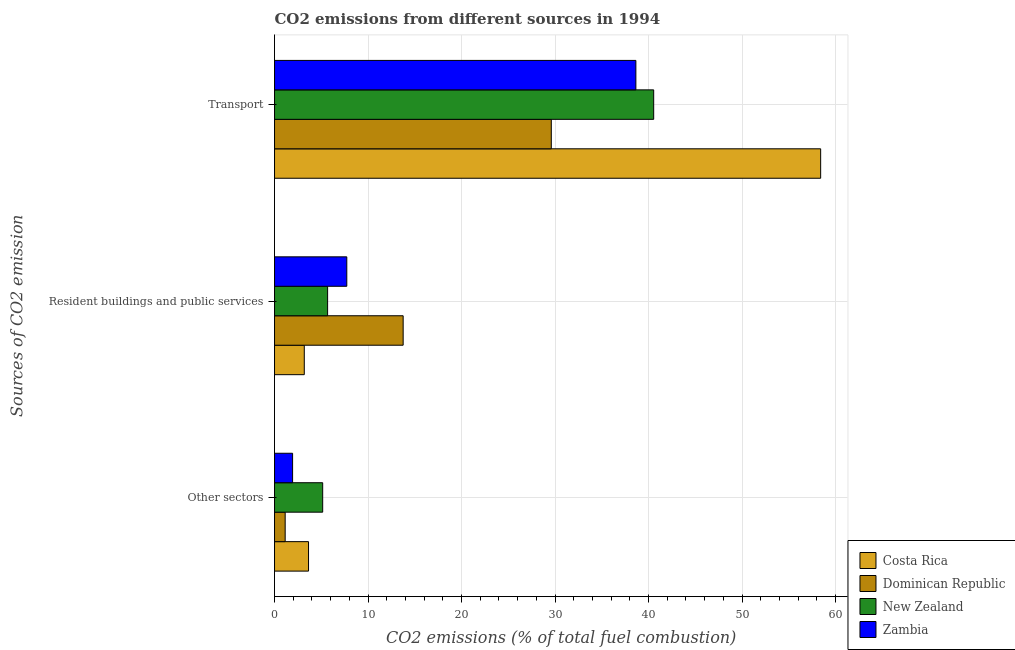How many groups of bars are there?
Your answer should be compact. 3. Are the number of bars per tick equal to the number of legend labels?
Ensure brevity in your answer.  Yes. How many bars are there on the 3rd tick from the top?
Keep it short and to the point. 4. What is the label of the 3rd group of bars from the top?
Offer a very short reply. Other sectors. What is the percentage of co2 emissions from transport in New Zealand?
Offer a very short reply. 40.55. Across all countries, what is the maximum percentage of co2 emissions from other sectors?
Ensure brevity in your answer.  5.15. Across all countries, what is the minimum percentage of co2 emissions from resident buildings and public services?
Your answer should be very brief. 3.18. In which country was the percentage of co2 emissions from resident buildings and public services maximum?
Make the answer very short. Dominican Republic. What is the total percentage of co2 emissions from other sectors in the graph?
Your answer should be very brief. 11.86. What is the difference between the percentage of co2 emissions from resident buildings and public services in Zambia and that in Dominican Republic?
Your answer should be very brief. -6.03. What is the difference between the percentage of co2 emissions from other sectors in Zambia and the percentage of co2 emissions from transport in Dominican Republic?
Your response must be concise. -27.67. What is the average percentage of co2 emissions from resident buildings and public services per country?
Offer a very short reply. 7.59. What is the difference between the percentage of co2 emissions from other sectors and percentage of co2 emissions from resident buildings and public services in Dominican Republic?
Your answer should be very brief. -12.62. What is the ratio of the percentage of co2 emissions from resident buildings and public services in Costa Rica to that in Dominican Republic?
Provide a short and direct response. 0.23. Is the difference between the percentage of co2 emissions from resident buildings and public services in New Zealand and Costa Rica greater than the difference between the percentage of co2 emissions from transport in New Zealand and Costa Rica?
Make the answer very short. Yes. What is the difference between the highest and the second highest percentage of co2 emissions from other sectors?
Give a very brief answer. 1.51. What is the difference between the highest and the lowest percentage of co2 emissions from resident buildings and public services?
Ensure brevity in your answer.  10.58. In how many countries, is the percentage of co2 emissions from transport greater than the average percentage of co2 emissions from transport taken over all countries?
Offer a very short reply. 1. Is the sum of the percentage of co2 emissions from transport in Costa Rica and Dominican Republic greater than the maximum percentage of co2 emissions from resident buildings and public services across all countries?
Your answer should be very brief. Yes. What does the 3rd bar from the top in Other sectors represents?
Your answer should be very brief. Dominican Republic. What does the 4th bar from the bottom in Resident buildings and public services represents?
Offer a terse response. Zambia. Are all the bars in the graph horizontal?
Keep it short and to the point. Yes. Does the graph contain any zero values?
Make the answer very short. No. How many legend labels are there?
Provide a succinct answer. 4. How are the legend labels stacked?
Give a very brief answer. Vertical. What is the title of the graph?
Make the answer very short. CO2 emissions from different sources in 1994. What is the label or title of the X-axis?
Offer a terse response. CO2 emissions (% of total fuel combustion). What is the label or title of the Y-axis?
Make the answer very short. Sources of CO2 emission. What is the CO2 emissions (% of total fuel combustion) of Costa Rica in Other sectors?
Your answer should be compact. 3.64. What is the CO2 emissions (% of total fuel combustion) of Dominican Republic in Other sectors?
Keep it short and to the point. 1.14. What is the CO2 emissions (% of total fuel combustion) in New Zealand in Other sectors?
Provide a short and direct response. 5.15. What is the CO2 emissions (% of total fuel combustion) in Zambia in Other sectors?
Offer a very short reply. 1.93. What is the CO2 emissions (% of total fuel combustion) of Costa Rica in Resident buildings and public services?
Keep it short and to the point. 3.18. What is the CO2 emissions (% of total fuel combustion) in Dominican Republic in Resident buildings and public services?
Make the answer very short. 13.76. What is the CO2 emissions (% of total fuel combustion) in New Zealand in Resident buildings and public services?
Your response must be concise. 5.68. What is the CO2 emissions (% of total fuel combustion) of Zambia in Resident buildings and public services?
Give a very brief answer. 7.73. What is the CO2 emissions (% of total fuel combustion) in Costa Rica in Transport?
Keep it short and to the point. 58.41. What is the CO2 emissions (% of total fuel combustion) in Dominican Republic in Transport?
Offer a very short reply. 29.6. What is the CO2 emissions (% of total fuel combustion) in New Zealand in Transport?
Keep it short and to the point. 40.55. What is the CO2 emissions (% of total fuel combustion) in Zambia in Transport?
Offer a terse response. 38.65. Across all Sources of CO2 emission, what is the maximum CO2 emissions (% of total fuel combustion) in Costa Rica?
Provide a short and direct response. 58.41. Across all Sources of CO2 emission, what is the maximum CO2 emissions (% of total fuel combustion) in Dominican Republic?
Ensure brevity in your answer.  29.6. Across all Sources of CO2 emission, what is the maximum CO2 emissions (% of total fuel combustion) of New Zealand?
Make the answer very short. 40.55. Across all Sources of CO2 emission, what is the maximum CO2 emissions (% of total fuel combustion) in Zambia?
Your answer should be compact. 38.65. Across all Sources of CO2 emission, what is the minimum CO2 emissions (% of total fuel combustion) in Costa Rica?
Offer a very short reply. 3.18. Across all Sources of CO2 emission, what is the minimum CO2 emissions (% of total fuel combustion) of Dominican Republic?
Your response must be concise. 1.14. Across all Sources of CO2 emission, what is the minimum CO2 emissions (% of total fuel combustion) of New Zealand?
Provide a short and direct response. 5.15. Across all Sources of CO2 emission, what is the minimum CO2 emissions (% of total fuel combustion) in Zambia?
Give a very brief answer. 1.93. What is the total CO2 emissions (% of total fuel combustion) in Costa Rica in the graph?
Provide a succinct answer. 65.23. What is the total CO2 emissions (% of total fuel combustion) in Dominican Republic in the graph?
Keep it short and to the point. 44.5. What is the total CO2 emissions (% of total fuel combustion) of New Zealand in the graph?
Give a very brief answer. 51.38. What is the total CO2 emissions (% of total fuel combustion) in Zambia in the graph?
Give a very brief answer. 48.31. What is the difference between the CO2 emissions (% of total fuel combustion) in Costa Rica in Other sectors and that in Resident buildings and public services?
Give a very brief answer. 0.45. What is the difference between the CO2 emissions (% of total fuel combustion) in Dominican Republic in Other sectors and that in Resident buildings and public services?
Give a very brief answer. -12.62. What is the difference between the CO2 emissions (% of total fuel combustion) in New Zealand in Other sectors and that in Resident buildings and public services?
Provide a short and direct response. -0.53. What is the difference between the CO2 emissions (% of total fuel combustion) of Zambia in Other sectors and that in Resident buildings and public services?
Provide a short and direct response. -5.8. What is the difference between the CO2 emissions (% of total fuel combustion) of Costa Rica in Other sectors and that in Transport?
Keep it short and to the point. -54.77. What is the difference between the CO2 emissions (% of total fuel combustion) of Dominican Republic in Other sectors and that in Transport?
Offer a very short reply. -28.46. What is the difference between the CO2 emissions (% of total fuel combustion) in New Zealand in Other sectors and that in Transport?
Offer a terse response. -35.4. What is the difference between the CO2 emissions (% of total fuel combustion) in Zambia in Other sectors and that in Transport?
Your answer should be compact. -36.72. What is the difference between the CO2 emissions (% of total fuel combustion) of Costa Rica in Resident buildings and public services and that in Transport?
Offer a terse response. -55.23. What is the difference between the CO2 emissions (% of total fuel combustion) in Dominican Republic in Resident buildings and public services and that in Transport?
Your answer should be compact. -15.84. What is the difference between the CO2 emissions (% of total fuel combustion) in New Zealand in Resident buildings and public services and that in Transport?
Provide a short and direct response. -34.87. What is the difference between the CO2 emissions (% of total fuel combustion) of Zambia in Resident buildings and public services and that in Transport?
Offer a terse response. -30.92. What is the difference between the CO2 emissions (% of total fuel combustion) of Costa Rica in Other sectors and the CO2 emissions (% of total fuel combustion) of Dominican Republic in Resident buildings and public services?
Offer a very short reply. -10.12. What is the difference between the CO2 emissions (% of total fuel combustion) of Costa Rica in Other sectors and the CO2 emissions (% of total fuel combustion) of New Zealand in Resident buildings and public services?
Your answer should be very brief. -2.04. What is the difference between the CO2 emissions (% of total fuel combustion) of Costa Rica in Other sectors and the CO2 emissions (% of total fuel combustion) of Zambia in Resident buildings and public services?
Keep it short and to the point. -4.09. What is the difference between the CO2 emissions (% of total fuel combustion) in Dominican Republic in Other sectors and the CO2 emissions (% of total fuel combustion) in New Zealand in Resident buildings and public services?
Provide a short and direct response. -4.54. What is the difference between the CO2 emissions (% of total fuel combustion) of Dominican Republic in Other sectors and the CO2 emissions (% of total fuel combustion) of Zambia in Resident buildings and public services?
Your answer should be compact. -6.59. What is the difference between the CO2 emissions (% of total fuel combustion) in New Zealand in Other sectors and the CO2 emissions (% of total fuel combustion) in Zambia in Resident buildings and public services?
Give a very brief answer. -2.58. What is the difference between the CO2 emissions (% of total fuel combustion) in Costa Rica in Other sectors and the CO2 emissions (% of total fuel combustion) in Dominican Republic in Transport?
Give a very brief answer. -25.97. What is the difference between the CO2 emissions (% of total fuel combustion) in Costa Rica in Other sectors and the CO2 emissions (% of total fuel combustion) in New Zealand in Transport?
Provide a short and direct response. -36.92. What is the difference between the CO2 emissions (% of total fuel combustion) of Costa Rica in Other sectors and the CO2 emissions (% of total fuel combustion) of Zambia in Transport?
Ensure brevity in your answer.  -35.01. What is the difference between the CO2 emissions (% of total fuel combustion) in Dominican Republic in Other sectors and the CO2 emissions (% of total fuel combustion) in New Zealand in Transport?
Ensure brevity in your answer.  -39.41. What is the difference between the CO2 emissions (% of total fuel combustion) in Dominican Republic in Other sectors and the CO2 emissions (% of total fuel combustion) in Zambia in Transport?
Provide a short and direct response. -37.51. What is the difference between the CO2 emissions (% of total fuel combustion) in New Zealand in Other sectors and the CO2 emissions (% of total fuel combustion) in Zambia in Transport?
Your answer should be compact. -33.5. What is the difference between the CO2 emissions (% of total fuel combustion) of Costa Rica in Resident buildings and public services and the CO2 emissions (% of total fuel combustion) of Dominican Republic in Transport?
Your answer should be compact. -26.42. What is the difference between the CO2 emissions (% of total fuel combustion) of Costa Rica in Resident buildings and public services and the CO2 emissions (% of total fuel combustion) of New Zealand in Transport?
Offer a very short reply. -37.37. What is the difference between the CO2 emissions (% of total fuel combustion) in Costa Rica in Resident buildings and public services and the CO2 emissions (% of total fuel combustion) in Zambia in Transport?
Make the answer very short. -35.47. What is the difference between the CO2 emissions (% of total fuel combustion) of Dominican Republic in Resident buildings and public services and the CO2 emissions (% of total fuel combustion) of New Zealand in Transport?
Your answer should be very brief. -26.79. What is the difference between the CO2 emissions (% of total fuel combustion) of Dominican Republic in Resident buildings and public services and the CO2 emissions (% of total fuel combustion) of Zambia in Transport?
Your response must be concise. -24.89. What is the difference between the CO2 emissions (% of total fuel combustion) in New Zealand in Resident buildings and public services and the CO2 emissions (% of total fuel combustion) in Zambia in Transport?
Offer a terse response. -32.97. What is the average CO2 emissions (% of total fuel combustion) of Costa Rica per Sources of CO2 emission?
Your answer should be compact. 21.74. What is the average CO2 emissions (% of total fuel combustion) of Dominican Republic per Sources of CO2 emission?
Provide a short and direct response. 14.83. What is the average CO2 emissions (% of total fuel combustion) of New Zealand per Sources of CO2 emission?
Make the answer very short. 17.13. What is the average CO2 emissions (% of total fuel combustion) in Zambia per Sources of CO2 emission?
Ensure brevity in your answer.  16.1. What is the difference between the CO2 emissions (% of total fuel combustion) of Costa Rica and CO2 emissions (% of total fuel combustion) of Dominican Republic in Other sectors?
Keep it short and to the point. 2.5. What is the difference between the CO2 emissions (% of total fuel combustion) in Costa Rica and CO2 emissions (% of total fuel combustion) in New Zealand in Other sectors?
Give a very brief answer. -1.51. What is the difference between the CO2 emissions (% of total fuel combustion) in Costa Rica and CO2 emissions (% of total fuel combustion) in Zambia in Other sectors?
Your response must be concise. 1.7. What is the difference between the CO2 emissions (% of total fuel combustion) of Dominican Republic and CO2 emissions (% of total fuel combustion) of New Zealand in Other sectors?
Your response must be concise. -4.01. What is the difference between the CO2 emissions (% of total fuel combustion) of Dominican Republic and CO2 emissions (% of total fuel combustion) of Zambia in Other sectors?
Keep it short and to the point. -0.79. What is the difference between the CO2 emissions (% of total fuel combustion) in New Zealand and CO2 emissions (% of total fuel combustion) in Zambia in Other sectors?
Offer a terse response. 3.22. What is the difference between the CO2 emissions (% of total fuel combustion) in Costa Rica and CO2 emissions (% of total fuel combustion) in Dominican Republic in Resident buildings and public services?
Your response must be concise. -10.58. What is the difference between the CO2 emissions (% of total fuel combustion) of Costa Rica and CO2 emissions (% of total fuel combustion) of New Zealand in Resident buildings and public services?
Provide a short and direct response. -2.5. What is the difference between the CO2 emissions (% of total fuel combustion) in Costa Rica and CO2 emissions (% of total fuel combustion) in Zambia in Resident buildings and public services?
Give a very brief answer. -4.55. What is the difference between the CO2 emissions (% of total fuel combustion) of Dominican Republic and CO2 emissions (% of total fuel combustion) of New Zealand in Resident buildings and public services?
Offer a very short reply. 8.08. What is the difference between the CO2 emissions (% of total fuel combustion) in Dominican Republic and CO2 emissions (% of total fuel combustion) in Zambia in Resident buildings and public services?
Keep it short and to the point. 6.03. What is the difference between the CO2 emissions (% of total fuel combustion) of New Zealand and CO2 emissions (% of total fuel combustion) of Zambia in Resident buildings and public services?
Your response must be concise. -2.05. What is the difference between the CO2 emissions (% of total fuel combustion) of Costa Rica and CO2 emissions (% of total fuel combustion) of Dominican Republic in Transport?
Provide a short and direct response. 28.81. What is the difference between the CO2 emissions (% of total fuel combustion) of Costa Rica and CO2 emissions (% of total fuel combustion) of New Zealand in Transport?
Keep it short and to the point. 17.86. What is the difference between the CO2 emissions (% of total fuel combustion) of Costa Rica and CO2 emissions (% of total fuel combustion) of Zambia in Transport?
Make the answer very short. 19.76. What is the difference between the CO2 emissions (% of total fuel combustion) in Dominican Republic and CO2 emissions (% of total fuel combustion) in New Zealand in Transport?
Provide a succinct answer. -10.95. What is the difference between the CO2 emissions (% of total fuel combustion) of Dominican Republic and CO2 emissions (% of total fuel combustion) of Zambia in Transport?
Your answer should be very brief. -9.05. What is the difference between the CO2 emissions (% of total fuel combustion) of New Zealand and CO2 emissions (% of total fuel combustion) of Zambia in Transport?
Keep it short and to the point. 1.9. What is the ratio of the CO2 emissions (% of total fuel combustion) of Dominican Republic in Other sectors to that in Resident buildings and public services?
Offer a very short reply. 0.08. What is the ratio of the CO2 emissions (% of total fuel combustion) in New Zealand in Other sectors to that in Resident buildings and public services?
Give a very brief answer. 0.91. What is the ratio of the CO2 emissions (% of total fuel combustion) in Costa Rica in Other sectors to that in Transport?
Your answer should be very brief. 0.06. What is the ratio of the CO2 emissions (% of total fuel combustion) of Dominican Republic in Other sectors to that in Transport?
Offer a terse response. 0.04. What is the ratio of the CO2 emissions (% of total fuel combustion) in New Zealand in Other sectors to that in Transport?
Your answer should be compact. 0.13. What is the ratio of the CO2 emissions (% of total fuel combustion) in Zambia in Other sectors to that in Transport?
Ensure brevity in your answer.  0.05. What is the ratio of the CO2 emissions (% of total fuel combustion) of Costa Rica in Resident buildings and public services to that in Transport?
Keep it short and to the point. 0.05. What is the ratio of the CO2 emissions (% of total fuel combustion) in Dominican Republic in Resident buildings and public services to that in Transport?
Keep it short and to the point. 0.46. What is the ratio of the CO2 emissions (% of total fuel combustion) in New Zealand in Resident buildings and public services to that in Transport?
Offer a terse response. 0.14. What is the ratio of the CO2 emissions (% of total fuel combustion) of Zambia in Resident buildings and public services to that in Transport?
Keep it short and to the point. 0.2. What is the difference between the highest and the second highest CO2 emissions (% of total fuel combustion) in Costa Rica?
Give a very brief answer. 54.77. What is the difference between the highest and the second highest CO2 emissions (% of total fuel combustion) of Dominican Republic?
Offer a very short reply. 15.84. What is the difference between the highest and the second highest CO2 emissions (% of total fuel combustion) in New Zealand?
Give a very brief answer. 34.87. What is the difference between the highest and the second highest CO2 emissions (% of total fuel combustion) in Zambia?
Offer a terse response. 30.92. What is the difference between the highest and the lowest CO2 emissions (% of total fuel combustion) of Costa Rica?
Offer a terse response. 55.23. What is the difference between the highest and the lowest CO2 emissions (% of total fuel combustion) in Dominican Republic?
Ensure brevity in your answer.  28.46. What is the difference between the highest and the lowest CO2 emissions (% of total fuel combustion) of New Zealand?
Your answer should be compact. 35.4. What is the difference between the highest and the lowest CO2 emissions (% of total fuel combustion) of Zambia?
Your response must be concise. 36.72. 